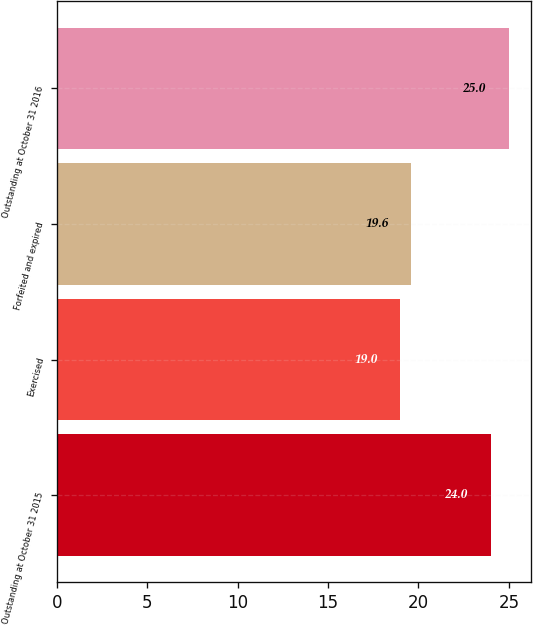Convert chart. <chart><loc_0><loc_0><loc_500><loc_500><bar_chart><fcel>Outstanding at October 31 2015<fcel>Exercised<fcel>Forfeited and expired<fcel>Outstanding at October 31 2016<nl><fcel>24<fcel>19<fcel>19.6<fcel>25<nl></chart> 